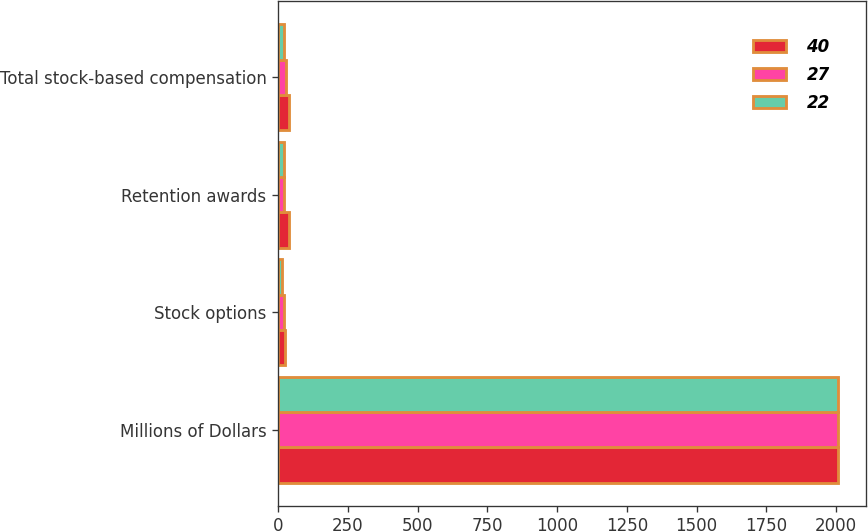<chart> <loc_0><loc_0><loc_500><loc_500><stacked_bar_chart><ecel><fcel>Millions of Dollars<fcel>Stock options<fcel>Retention awards<fcel>Total stock-based compensation<nl><fcel>40<fcel>2008<fcel>25<fcel>40<fcel>40<nl><fcel>27<fcel>2007<fcel>21<fcel>23<fcel>27<nl><fcel>22<fcel>2006<fcel>14<fcel>21<fcel>22<nl></chart> 